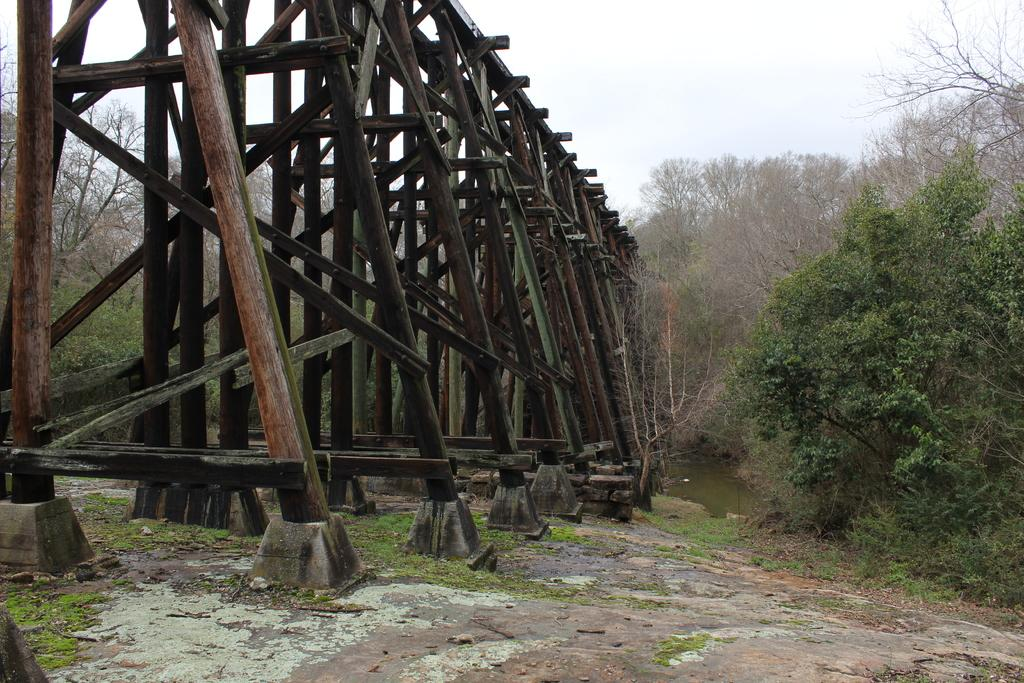What is located on the left side of the image in the foreground? There is a wooden pole structure on the left side in the foreground of the image. What can be seen in the background of the image? There are trees and the sky visible in the background of the image. How many dolls are sitting on the wooden pole structure in the image? There are no dolls present in the image; it features a wooden pole structure and trees in the background. Can you see any ducks swimming in the sky in the image? There are no ducks visible in the image, as it features a wooden pole structure, trees, and the sky in the background. 